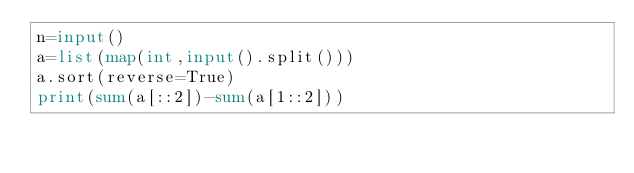<code> <loc_0><loc_0><loc_500><loc_500><_Python_>n=input()
a=list(map(int,input().split()))
a.sort(reverse=True)
print(sum(a[::2])-sum(a[1::2]))</code> 